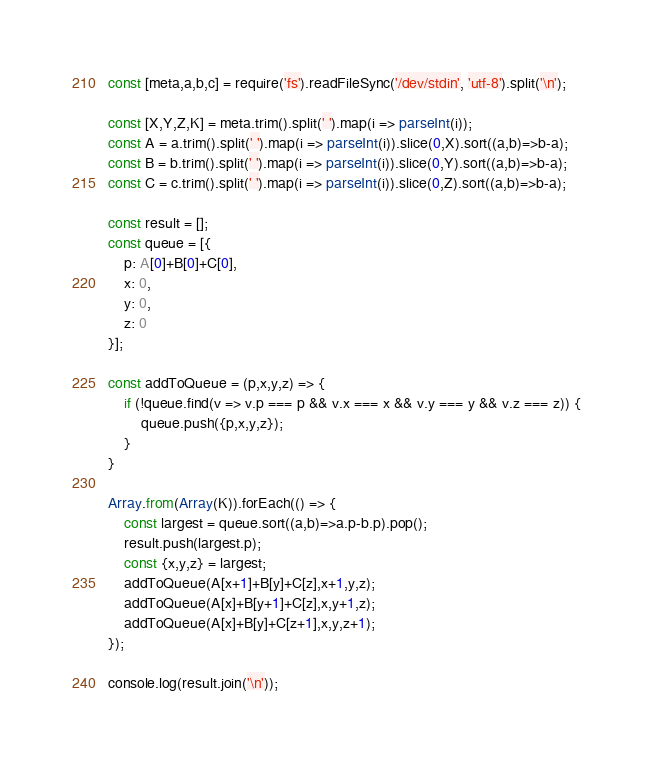Convert code to text. <code><loc_0><loc_0><loc_500><loc_500><_TypeScript_>const [meta,a,b,c] = require('fs').readFileSync('/dev/stdin', 'utf-8').split('\n');

const [X,Y,Z,K] = meta.trim().split(' ').map(i => parseInt(i));
const A = a.trim().split(' ').map(i => parseInt(i)).slice(0,X).sort((a,b)=>b-a);
const B = b.trim().split(' ').map(i => parseInt(i)).slice(0,Y).sort((a,b)=>b-a);
const C = c.trim().split(' ').map(i => parseInt(i)).slice(0,Z).sort((a,b)=>b-a);

const result = [];
const queue = [{
    p: A[0]+B[0]+C[0],
    x: 0,
    y: 0,
    z: 0
}];

const addToQueue = (p,x,y,z) => {
    if (!queue.find(v => v.p === p && v.x === x && v.y === y && v.z === z)) {
        queue.push({p,x,y,z});
    }
}

Array.from(Array(K)).forEach(() => {
    const largest = queue.sort((a,b)=>a.p-b.p).pop();
    result.push(largest.p);
    const {x,y,z} = largest;
    addToQueue(A[x+1]+B[y]+C[z],x+1,y,z);
    addToQueue(A[x]+B[y+1]+C[z],x,y+1,z);
    addToQueue(A[x]+B[y]+C[z+1],x,y,z+1);
});

console.log(result.join('\n'));</code> 